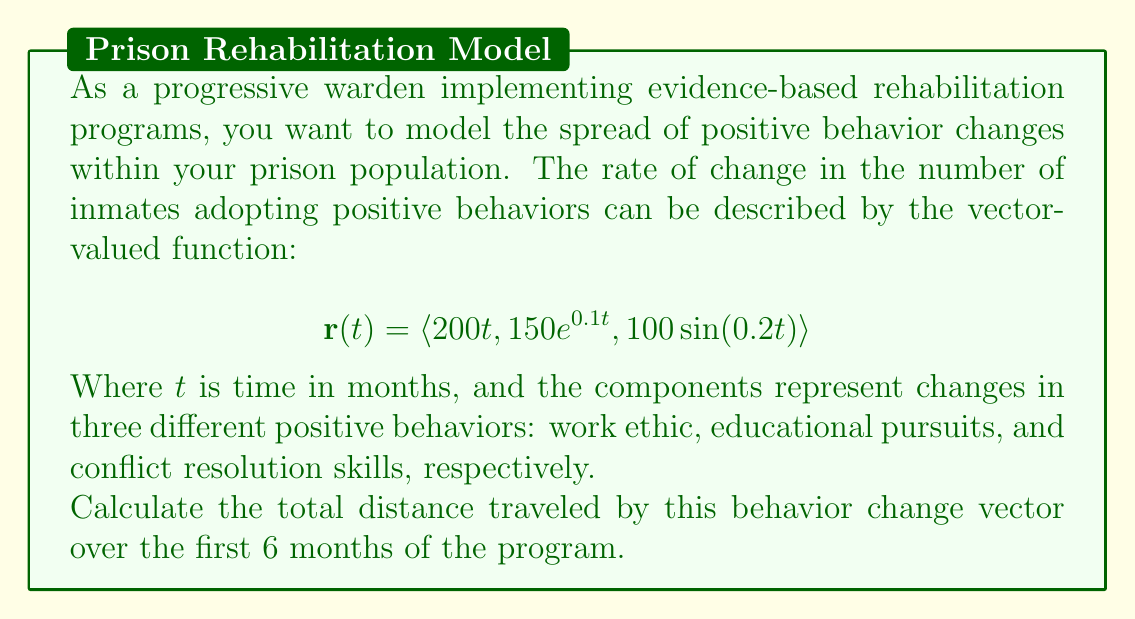Help me with this question. To solve this problem, we need to follow these steps:

1) The total distance traveled by a vector-valued function is given by the arc length formula:

   $$L = \int_a^b |\mathbf{r}'(t)| dt$$

2) First, we need to find $\mathbf{r}'(t)$:
   
   $$\mathbf{r}'(t) = \langle 200, 15e^{0.1t}, 20\cos(0.2t) \rangle$$

3) Now, we need to calculate $|\mathbf{r}'(t)|$:

   $$|\mathbf{r}'(t)| = \sqrt{(200)^2 + (15e^{0.1t})^2 + (20\cos(0.2t))^2}$$

4) Substituting this into the arc length formula:

   $$L = \int_0^6 \sqrt{40000 + 225e^{0.2t} + 400\cos^2(0.2t)} dt$$

5) This integral is too complex to solve analytically. We need to use numerical integration methods, such as the trapezoidal rule or Simpson's rule, to approximate the result.

6) Using computational tools to perform the numerical integration from 0 to 6, we get:

   $$L \approx 1215.32$$

Therefore, the total distance traveled by the behavior change vector over the first 6 months is approximately 1215.32 units.
Answer: The total distance traveled by the behavior change vector over the first 6 months is approximately 1215.32 units. 